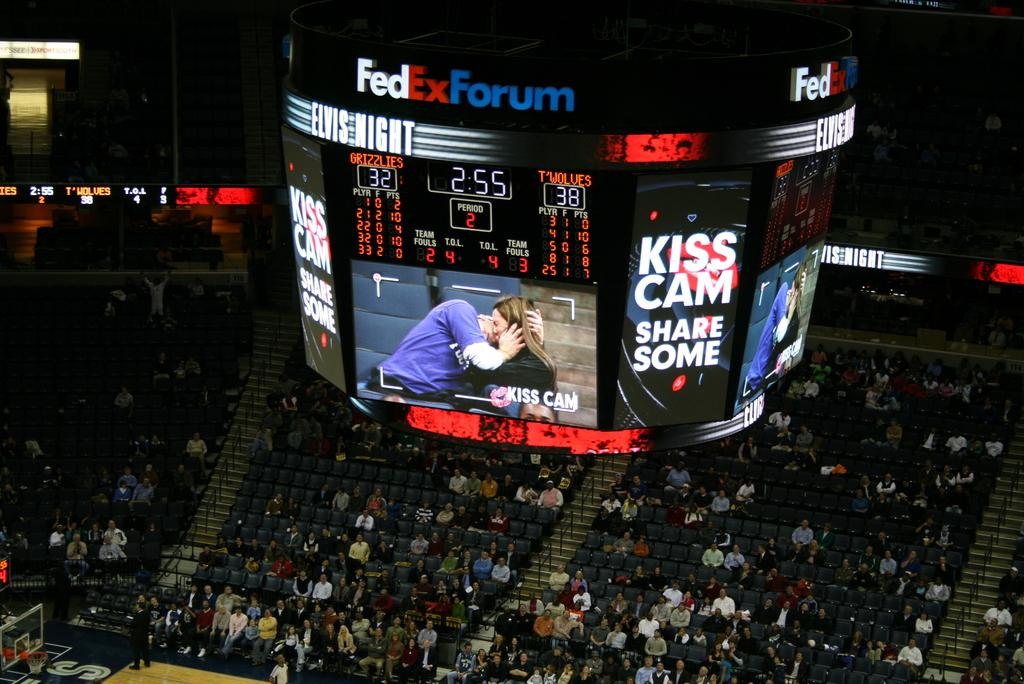<image>
Describe the image concisely. A studium with people sitting in it with a huge teletron that says FedEx Forum. 